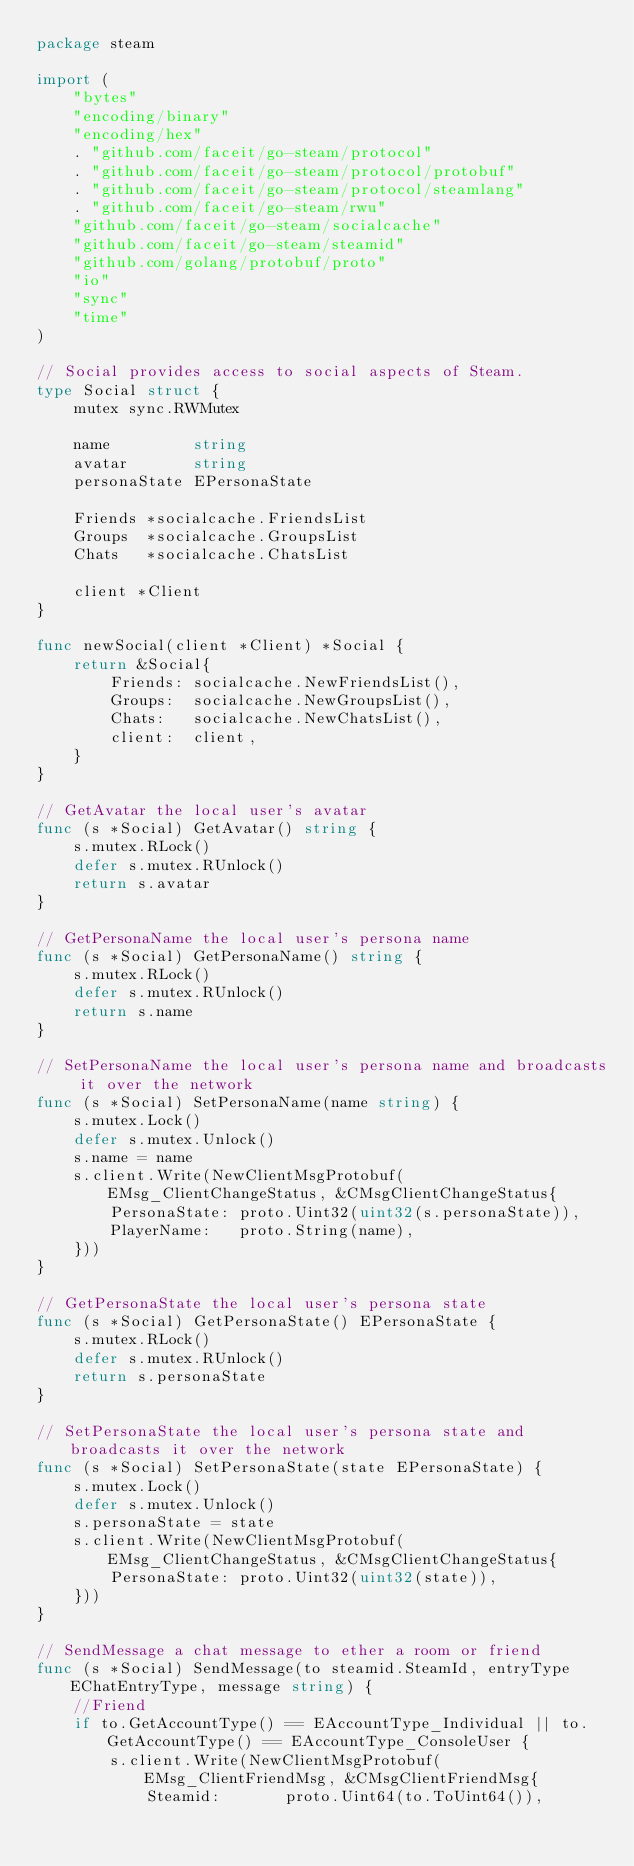<code> <loc_0><loc_0><loc_500><loc_500><_Go_>package steam

import (
	"bytes"
	"encoding/binary"
	"encoding/hex"
	. "github.com/faceit/go-steam/protocol"
	. "github.com/faceit/go-steam/protocol/protobuf"
	. "github.com/faceit/go-steam/protocol/steamlang"
	. "github.com/faceit/go-steam/rwu"
	"github.com/faceit/go-steam/socialcache"
	"github.com/faceit/go-steam/steamid"
	"github.com/golang/protobuf/proto"
	"io"
	"sync"
	"time"
)

// Social provides access to social aspects of Steam.
type Social struct {
	mutex sync.RWMutex

	name         string
	avatar       string
	personaState EPersonaState

	Friends *socialcache.FriendsList
	Groups  *socialcache.GroupsList
	Chats   *socialcache.ChatsList

	client *Client
}

func newSocial(client *Client) *Social {
	return &Social{
		Friends: socialcache.NewFriendsList(),
		Groups:  socialcache.NewGroupsList(),
		Chats:   socialcache.NewChatsList(),
		client:  client,
	}
}

// GetAvatar the local user's avatar
func (s *Social) GetAvatar() string {
	s.mutex.RLock()
	defer s.mutex.RUnlock()
	return s.avatar
}

// GetPersonaName the local user's persona name
func (s *Social) GetPersonaName() string {
	s.mutex.RLock()
	defer s.mutex.RUnlock()
	return s.name
}

// SetPersonaName the local user's persona name and broadcasts it over the network
func (s *Social) SetPersonaName(name string) {
	s.mutex.Lock()
	defer s.mutex.Unlock()
	s.name = name
	s.client.Write(NewClientMsgProtobuf(EMsg_ClientChangeStatus, &CMsgClientChangeStatus{
		PersonaState: proto.Uint32(uint32(s.personaState)),
		PlayerName:   proto.String(name),
	}))
}

// GetPersonaState the local user's persona state
func (s *Social) GetPersonaState() EPersonaState {
	s.mutex.RLock()
	defer s.mutex.RUnlock()
	return s.personaState
}

// SetPersonaState the local user's persona state and broadcasts it over the network
func (s *Social) SetPersonaState(state EPersonaState) {
	s.mutex.Lock()
	defer s.mutex.Unlock()
	s.personaState = state
	s.client.Write(NewClientMsgProtobuf(EMsg_ClientChangeStatus, &CMsgClientChangeStatus{
		PersonaState: proto.Uint32(uint32(state)),
	}))
}

// SendMessage a chat message to ether a room or friend
func (s *Social) SendMessage(to steamid.SteamId, entryType EChatEntryType, message string) {
	//Friend
	if to.GetAccountType() == EAccountType_Individual || to.GetAccountType() == EAccountType_ConsoleUser {
		s.client.Write(NewClientMsgProtobuf(EMsg_ClientFriendMsg, &CMsgClientFriendMsg{
			Steamid:       proto.Uint64(to.ToUint64()),</code> 